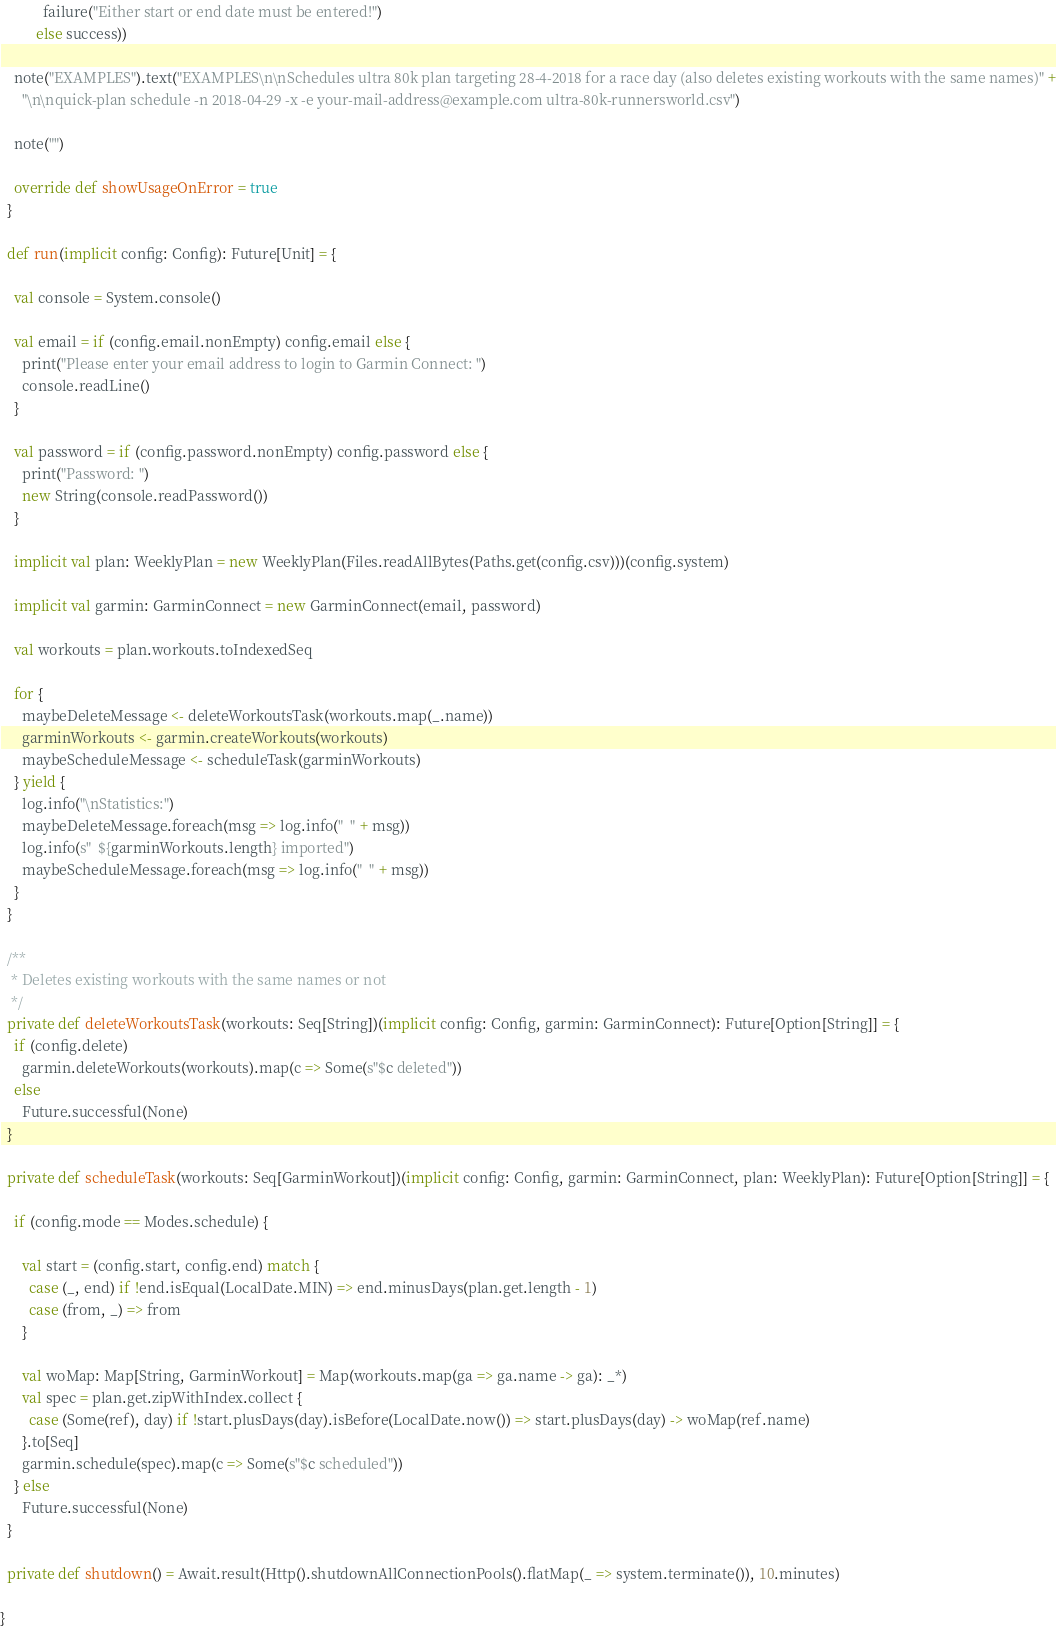Convert code to text. <code><loc_0><loc_0><loc_500><loc_500><_Scala_>            failure("Either start or end date must be entered!")
          else success))

    note("EXAMPLES").text("EXAMPLES\n\nSchedules ultra 80k plan targeting 28-4-2018 for a race day (also deletes existing workouts with the same names)" +
      "\n\nquick-plan schedule -n 2018-04-29 -x -e your-mail-address@example.com ultra-80k-runnersworld.csv")

    note("")

    override def showUsageOnError = true
  }

  def run(implicit config: Config): Future[Unit] = {

    val console = System.console()

    val email = if (config.email.nonEmpty) config.email else {
      print("Please enter your email address to login to Garmin Connect: ")
      console.readLine()
    }

    val password = if (config.password.nonEmpty) config.password else {
      print("Password: ")
      new String(console.readPassword())
    }

    implicit val plan: WeeklyPlan = new WeeklyPlan(Files.readAllBytes(Paths.get(config.csv)))(config.system)

    implicit val garmin: GarminConnect = new GarminConnect(email, password)

    val workouts = plan.workouts.toIndexedSeq

    for {
      maybeDeleteMessage <- deleteWorkoutsTask(workouts.map(_.name))
      garminWorkouts <- garmin.createWorkouts(workouts)
      maybeScheduleMessage <- scheduleTask(garminWorkouts)
    } yield {
      log.info("\nStatistics:")
      maybeDeleteMessage.foreach(msg => log.info("  " + msg))
      log.info(s"  ${garminWorkouts.length} imported")
      maybeScheduleMessage.foreach(msg => log.info("  " + msg))
    }
  }

  /**
   * Deletes existing workouts with the same names or not
   */
  private def deleteWorkoutsTask(workouts: Seq[String])(implicit config: Config, garmin: GarminConnect): Future[Option[String]] = {
    if (config.delete)
      garmin.deleteWorkouts(workouts).map(c => Some(s"$c deleted"))
    else
      Future.successful(None)
  }

  private def scheduleTask(workouts: Seq[GarminWorkout])(implicit config: Config, garmin: GarminConnect, plan: WeeklyPlan): Future[Option[String]] = {

    if (config.mode == Modes.schedule) {

      val start = (config.start, config.end) match {
        case (_, end) if !end.isEqual(LocalDate.MIN) => end.minusDays(plan.get.length - 1)
        case (from, _) => from
      }

      val woMap: Map[String, GarminWorkout] = Map(workouts.map(ga => ga.name -> ga): _*)
      val spec = plan.get.zipWithIndex.collect {
        case (Some(ref), day) if !start.plusDays(day).isBefore(LocalDate.now()) => start.plusDays(day) -> woMap(ref.name)
      }.to[Seq]
      garmin.schedule(spec).map(c => Some(s"$c scheduled"))
    } else
      Future.successful(None)
  }

  private def shutdown() = Await.result(Http().shutdownAllConnectionPools().flatMap(_ => system.terminate()), 10.minutes)

}
</code> 